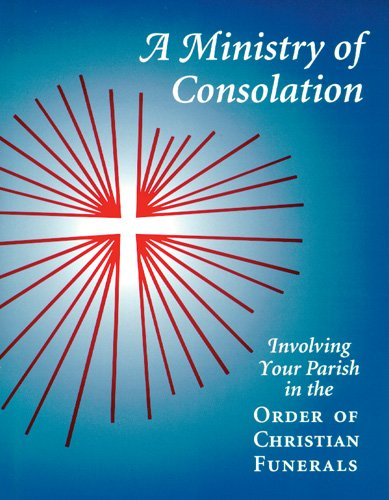Who wrote this book? The book, 'A Ministry of Consolation: Involving Your Parish in the Order of Christian Funerals', was authored by Mary Alice Piil CSJ. 